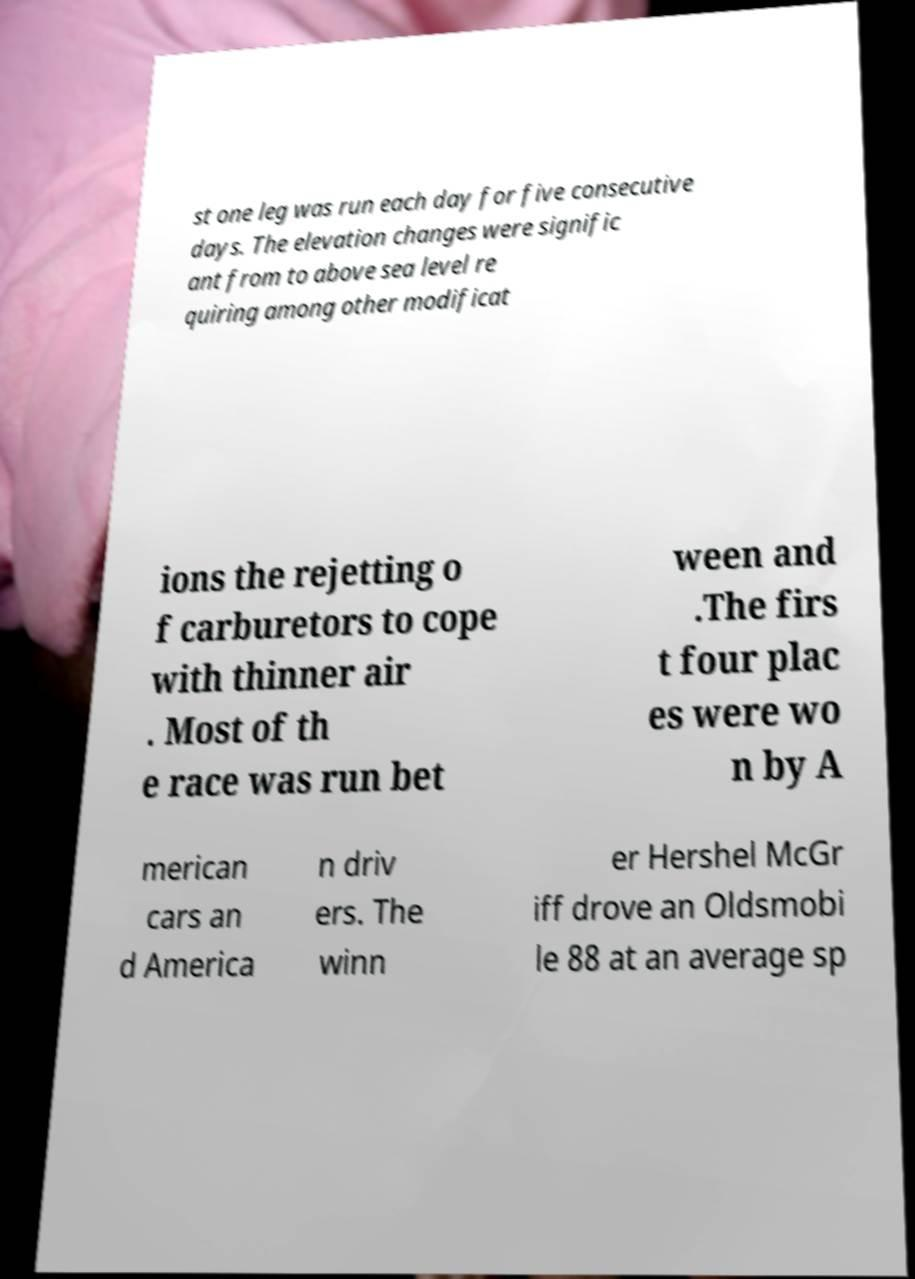There's text embedded in this image that I need extracted. Can you transcribe it verbatim? st one leg was run each day for five consecutive days. The elevation changes were signific ant from to above sea level re quiring among other modificat ions the rejetting o f carburetors to cope with thinner air . Most of th e race was run bet ween and .The firs t four plac es were wo n by A merican cars an d America n driv ers. The winn er Hershel McGr iff drove an Oldsmobi le 88 at an average sp 